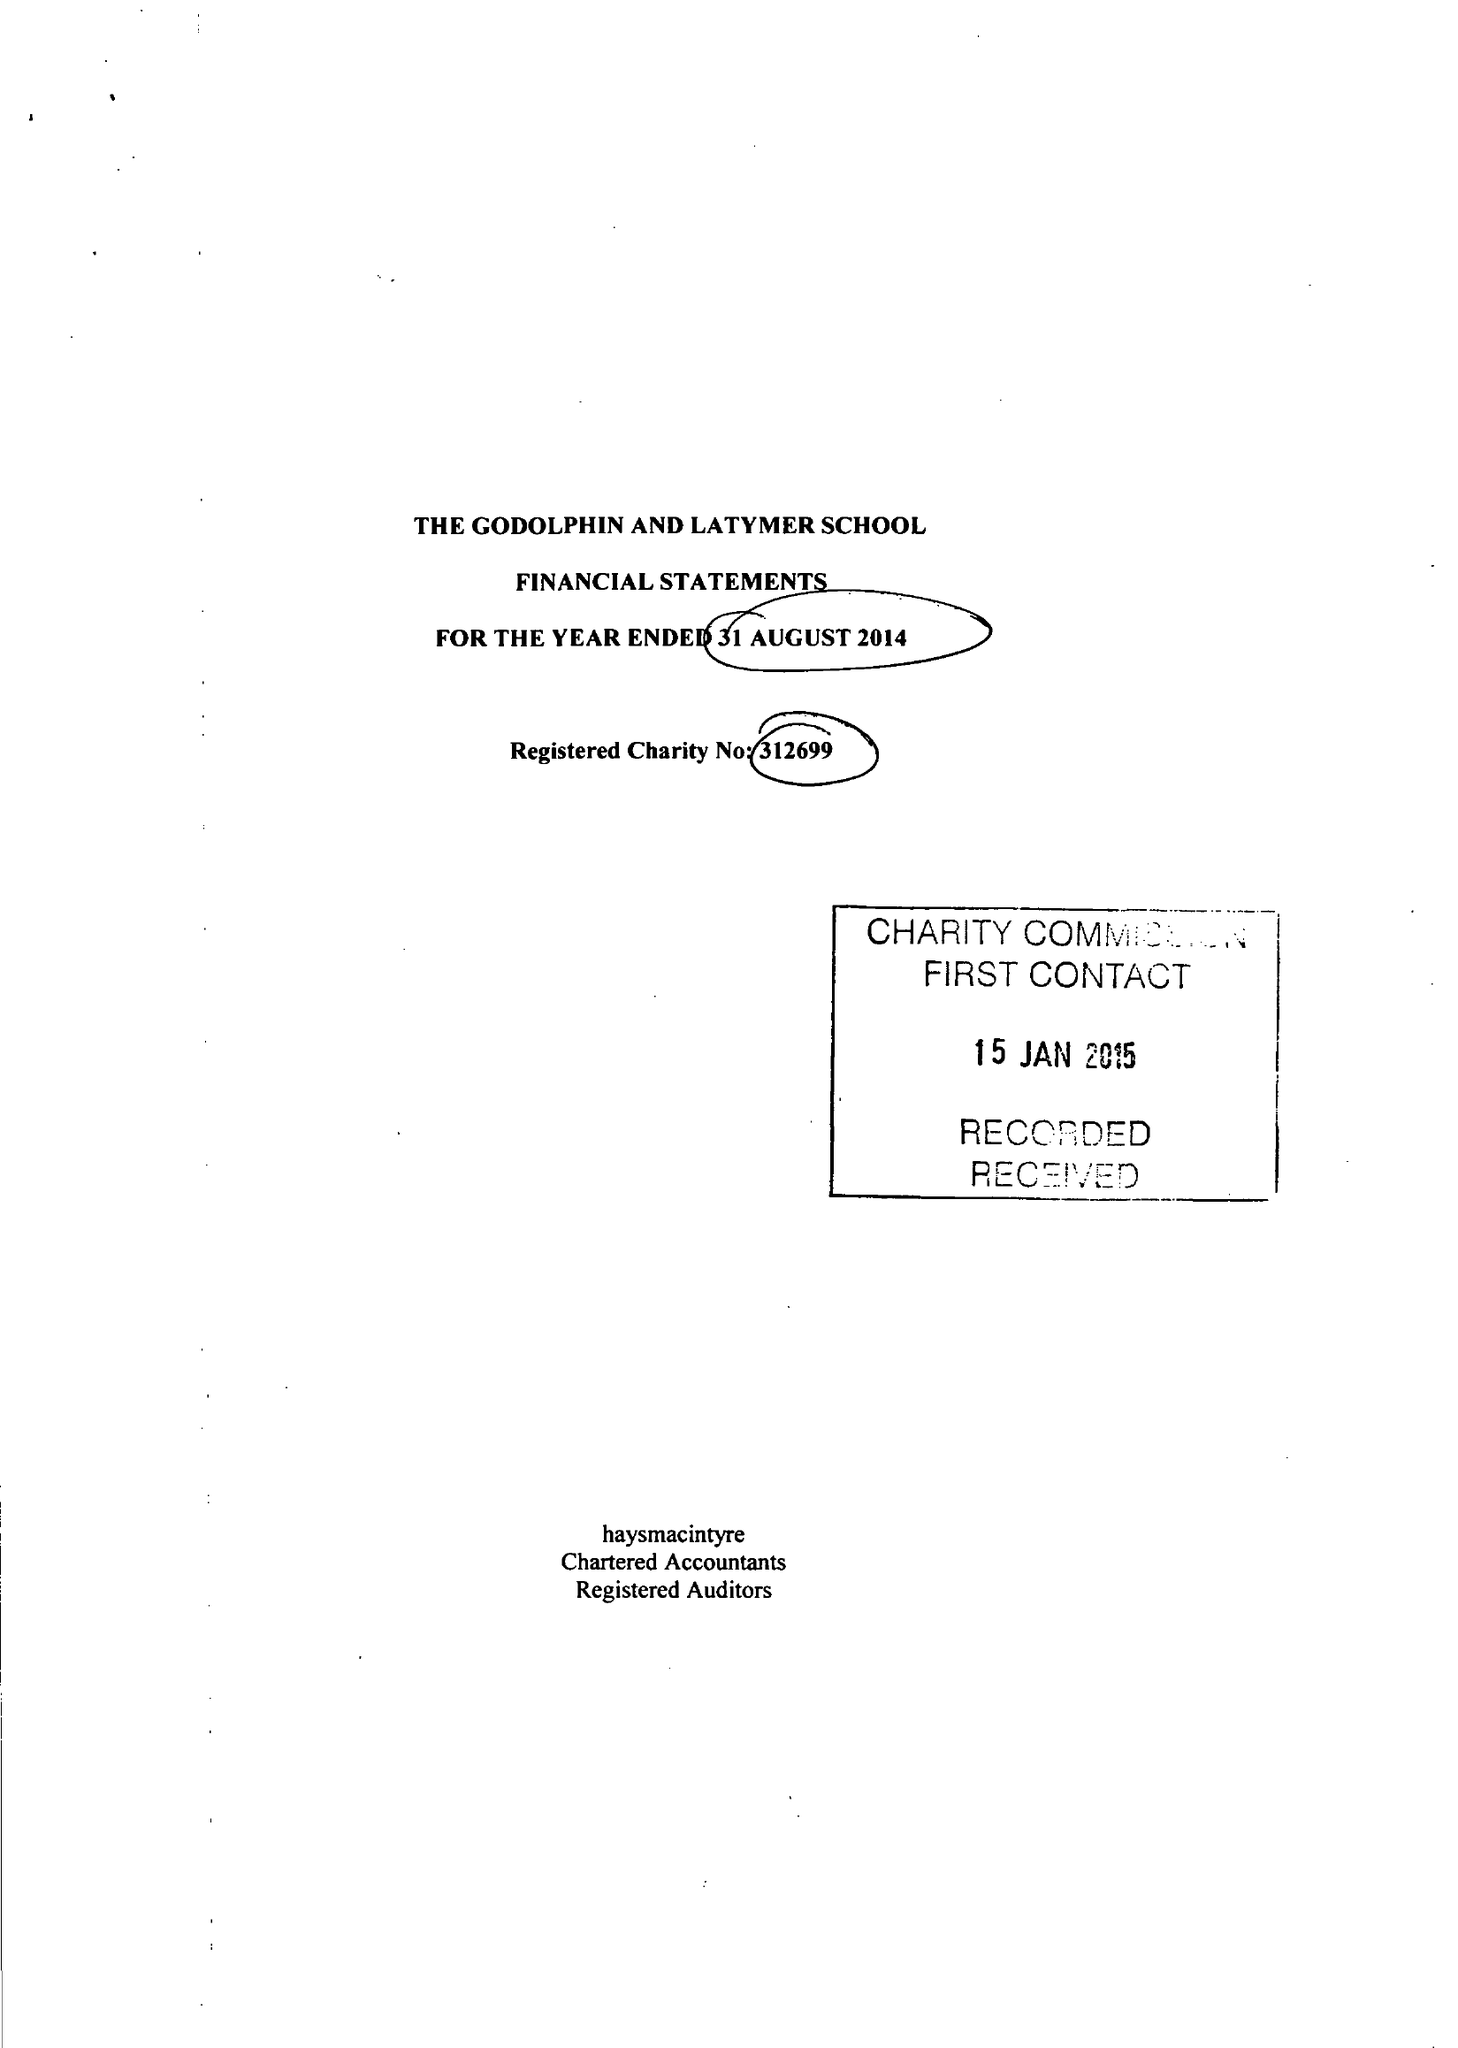What is the value for the address__post_town?
Answer the question using a single word or phrase. LONDON 